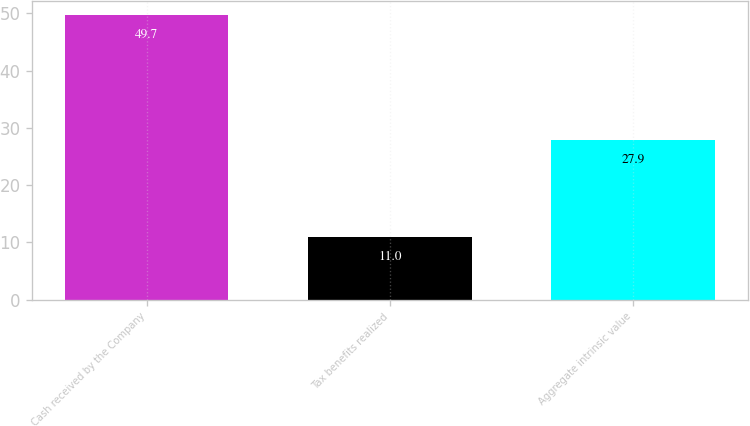Convert chart to OTSL. <chart><loc_0><loc_0><loc_500><loc_500><bar_chart><fcel>Cash received by the Company<fcel>Tax benefits realized<fcel>Aggregate intrinsic value<nl><fcel>49.7<fcel>11<fcel>27.9<nl></chart> 